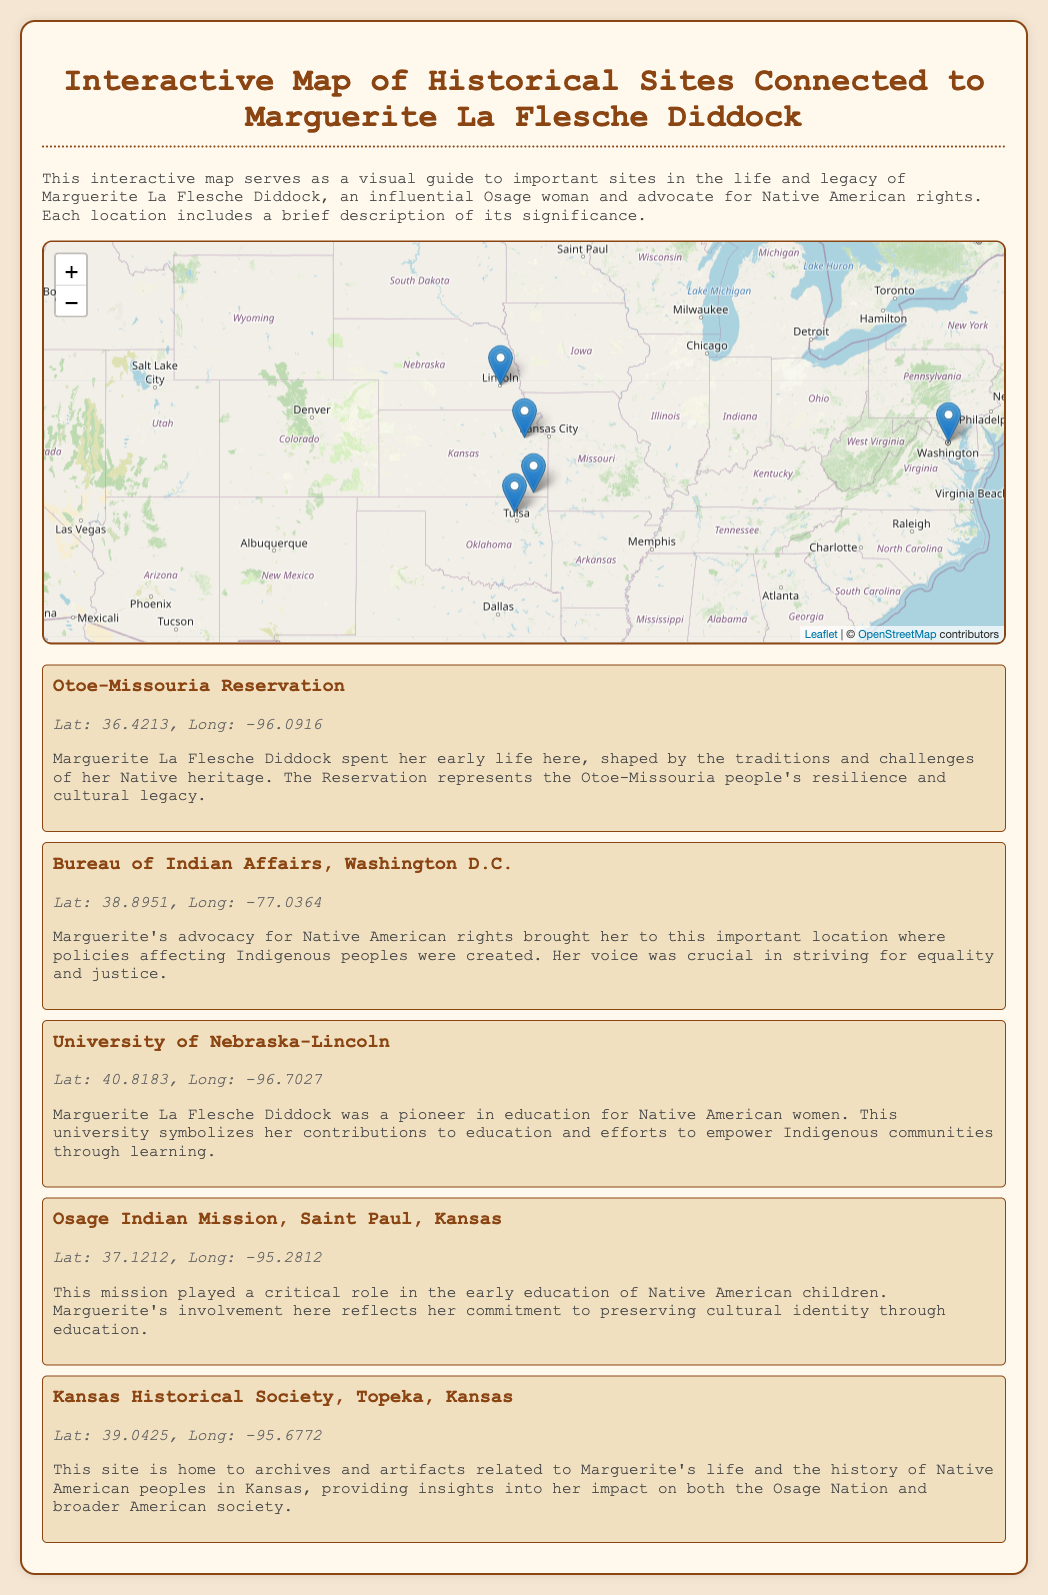What is the title of the document? The title of the document is prominently displayed at the top, stating the focus on Marguerite La Flesche Diddock's legacy.
Answer: Interactive Map of Historical Sites Connected to Marguerite La Flesche Diddock How many locations are featured on the map? The map details five distinct locations connected to Marguerite's life and legacy, each marked on the interactive map.
Answer: Five Which reservation is mentioned for Marguerite's early life? The significance section of the document specifically identifies the location related to Marguerite's early life.
Answer: Otoe-Missouria Reservation What is the latitude of the Bureau of Indian Affairs? The coordinates for the Bureau of Indian Affairs are provided in the document, making it possible to retrieve this information.
Answer: 38.8951 What role did Marguerite play at the Osage Indian Mission? The document describes her involvement and commitment to preserving cultural identity through education at this site.
Answer: Education Where is the Kansas Historical Society located? The coordinates for the Kansas Historical Society are clearly provided in the locations section for geographic reference.
Answer: Topeka, Kansas Why is the University of Nebraska-Lincoln significant? The document outlines its importance in terms of Marguerite's contributions to education and empowerment of Indigenous communities.
Answer: Education What type of map is presented in the document? The document introduces a specific type of visual tool designed to illustrate historical connections, categorized based on the content it covers.
Answer: Interactive map 